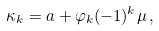Convert formula to latex. <formula><loc_0><loc_0><loc_500><loc_500>\kappa _ { k } = a + \varphi _ { k } ( - 1 ) ^ { k } \mu \, ,</formula> 